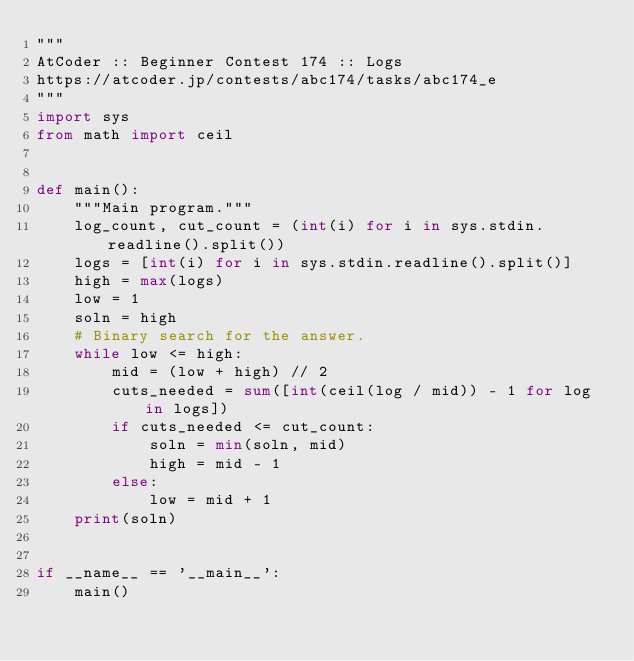<code> <loc_0><loc_0><loc_500><loc_500><_Python_>"""
AtCoder :: Beginner Contest 174 :: Logs
https://atcoder.jp/contests/abc174/tasks/abc174_e
"""
import sys
from math import ceil


def main():
    """Main program."""
    log_count, cut_count = (int(i) for i in sys.stdin.readline().split())
    logs = [int(i) for i in sys.stdin.readline().split()]
    high = max(logs)
    low = 1
    soln = high
    # Binary search for the answer.
    while low <= high:
        mid = (low + high) // 2
        cuts_needed = sum([int(ceil(log / mid)) - 1 for log in logs])
        if cuts_needed <= cut_count:
            soln = min(soln, mid)
            high = mid - 1
        else:
            low = mid + 1
    print(soln)


if __name__ == '__main__':
    main()
</code> 